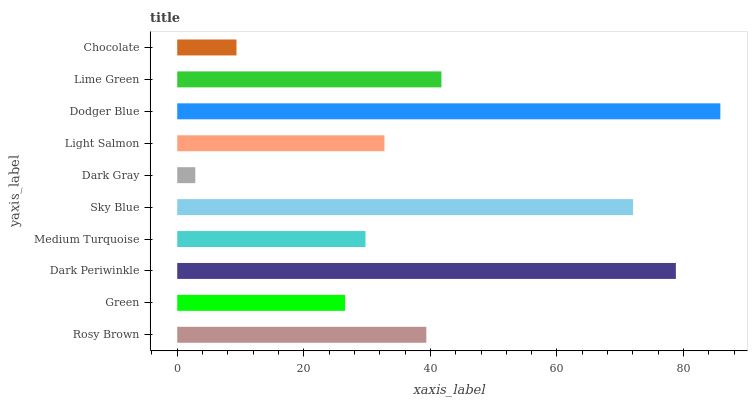Is Dark Gray the minimum?
Answer yes or no. Yes. Is Dodger Blue the maximum?
Answer yes or no. Yes. Is Green the minimum?
Answer yes or no. No. Is Green the maximum?
Answer yes or no. No. Is Rosy Brown greater than Green?
Answer yes or no. Yes. Is Green less than Rosy Brown?
Answer yes or no. Yes. Is Green greater than Rosy Brown?
Answer yes or no. No. Is Rosy Brown less than Green?
Answer yes or no. No. Is Rosy Brown the high median?
Answer yes or no. Yes. Is Light Salmon the low median?
Answer yes or no. Yes. Is Sky Blue the high median?
Answer yes or no. No. Is Sky Blue the low median?
Answer yes or no. No. 